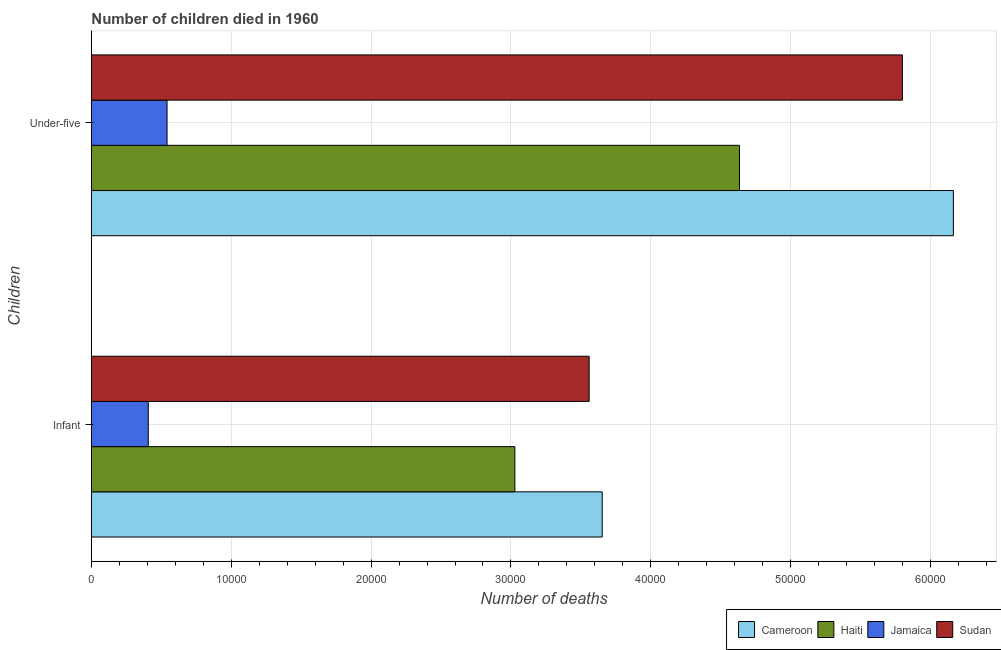Are the number of bars per tick equal to the number of legend labels?
Keep it short and to the point. Yes. How many bars are there on the 2nd tick from the bottom?
Keep it short and to the point. 4. What is the label of the 1st group of bars from the top?
Offer a terse response. Under-five. What is the number of infant deaths in Sudan?
Give a very brief answer. 3.56e+04. Across all countries, what is the maximum number of infant deaths?
Your answer should be very brief. 3.65e+04. Across all countries, what is the minimum number of under-five deaths?
Provide a short and direct response. 5408. In which country was the number of under-five deaths maximum?
Provide a short and direct response. Cameroon. In which country was the number of under-five deaths minimum?
Your answer should be compact. Jamaica. What is the total number of under-five deaths in the graph?
Offer a terse response. 1.71e+05. What is the difference between the number of infant deaths in Haiti and that in Jamaica?
Offer a terse response. 2.62e+04. What is the difference between the number of infant deaths in Cameroon and the number of under-five deaths in Sudan?
Offer a terse response. -2.15e+04. What is the average number of infant deaths per country?
Your response must be concise. 2.66e+04. What is the difference between the number of infant deaths and number of under-five deaths in Haiti?
Your answer should be compact. -1.61e+04. What is the ratio of the number of infant deaths in Sudan to that in Jamaica?
Your answer should be compact. 8.76. What does the 1st bar from the top in Under-five represents?
Your answer should be compact. Sudan. What does the 4th bar from the bottom in Infant represents?
Provide a short and direct response. Sudan. What is the difference between two consecutive major ticks on the X-axis?
Make the answer very short. 10000. Are the values on the major ticks of X-axis written in scientific E-notation?
Keep it short and to the point. No. Does the graph contain any zero values?
Provide a short and direct response. No. Does the graph contain grids?
Offer a terse response. Yes. How are the legend labels stacked?
Provide a short and direct response. Horizontal. What is the title of the graph?
Keep it short and to the point. Number of children died in 1960. What is the label or title of the X-axis?
Keep it short and to the point. Number of deaths. What is the label or title of the Y-axis?
Offer a very short reply. Children. What is the Number of deaths in Cameroon in Infant?
Your answer should be very brief. 3.65e+04. What is the Number of deaths in Haiti in Infant?
Provide a short and direct response. 3.03e+04. What is the Number of deaths in Jamaica in Infant?
Your answer should be compact. 4065. What is the Number of deaths in Sudan in Infant?
Keep it short and to the point. 3.56e+04. What is the Number of deaths in Cameroon in Under-five?
Your response must be concise. 6.16e+04. What is the Number of deaths of Haiti in Under-five?
Give a very brief answer. 4.63e+04. What is the Number of deaths of Jamaica in Under-five?
Provide a succinct answer. 5408. What is the Number of deaths in Sudan in Under-five?
Offer a terse response. 5.80e+04. Across all Children, what is the maximum Number of deaths in Cameroon?
Make the answer very short. 6.16e+04. Across all Children, what is the maximum Number of deaths of Haiti?
Your answer should be very brief. 4.63e+04. Across all Children, what is the maximum Number of deaths in Jamaica?
Provide a short and direct response. 5408. Across all Children, what is the maximum Number of deaths of Sudan?
Keep it short and to the point. 5.80e+04. Across all Children, what is the minimum Number of deaths of Cameroon?
Make the answer very short. 3.65e+04. Across all Children, what is the minimum Number of deaths in Haiti?
Provide a short and direct response. 3.03e+04. Across all Children, what is the minimum Number of deaths of Jamaica?
Your response must be concise. 4065. Across all Children, what is the minimum Number of deaths of Sudan?
Provide a succinct answer. 3.56e+04. What is the total Number of deaths of Cameroon in the graph?
Give a very brief answer. 9.82e+04. What is the total Number of deaths in Haiti in the graph?
Provide a short and direct response. 7.66e+04. What is the total Number of deaths of Jamaica in the graph?
Ensure brevity in your answer.  9473. What is the total Number of deaths in Sudan in the graph?
Your response must be concise. 9.36e+04. What is the difference between the Number of deaths in Cameroon in Infant and that in Under-five?
Offer a terse response. -2.51e+04. What is the difference between the Number of deaths of Haiti in Infant and that in Under-five?
Provide a succinct answer. -1.61e+04. What is the difference between the Number of deaths in Jamaica in Infant and that in Under-five?
Ensure brevity in your answer.  -1343. What is the difference between the Number of deaths in Sudan in Infant and that in Under-five?
Provide a succinct answer. -2.24e+04. What is the difference between the Number of deaths in Cameroon in Infant and the Number of deaths in Haiti in Under-five?
Give a very brief answer. -9816. What is the difference between the Number of deaths of Cameroon in Infant and the Number of deaths of Jamaica in Under-five?
Your response must be concise. 3.11e+04. What is the difference between the Number of deaths in Cameroon in Infant and the Number of deaths in Sudan in Under-five?
Make the answer very short. -2.15e+04. What is the difference between the Number of deaths of Haiti in Infant and the Number of deaths of Jamaica in Under-five?
Keep it short and to the point. 2.49e+04. What is the difference between the Number of deaths of Haiti in Infant and the Number of deaths of Sudan in Under-five?
Make the answer very short. -2.77e+04. What is the difference between the Number of deaths in Jamaica in Infant and the Number of deaths in Sudan in Under-five?
Your answer should be very brief. -5.39e+04. What is the average Number of deaths in Cameroon per Children?
Offer a terse response. 4.91e+04. What is the average Number of deaths in Haiti per Children?
Make the answer very short. 3.83e+04. What is the average Number of deaths in Jamaica per Children?
Give a very brief answer. 4736.5. What is the average Number of deaths of Sudan per Children?
Provide a succinct answer. 4.68e+04. What is the difference between the Number of deaths of Cameroon and Number of deaths of Haiti in Infant?
Keep it short and to the point. 6246. What is the difference between the Number of deaths in Cameroon and Number of deaths in Jamaica in Infant?
Provide a short and direct response. 3.25e+04. What is the difference between the Number of deaths in Cameroon and Number of deaths in Sudan in Infant?
Your answer should be very brief. 935. What is the difference between the Number of deaths in Haiti and Number of deaths in Jamaica in Infant?
Give a very brief answer. 2.62e+04. What is the difference between the Number of deaths in Haiti and Number of deaths in Sudan in Infant?
Provide a succinct answer. -5311. What is the difference between the Number of deaths in Jamaica and Number of deaths in Sudan in Infant?
Your answer should be very brief. -3.15e+04. What is the difference between the Number of deaths in Cameroon and Number of deaths in Haiti in Under-five?
Ensure brevity in your answer.  1.53e+04. What is the difference between the Number of deaths of Cameroon and Number of deaths of Jamaica in Under-five?
Your answer should be compact. 5.62e+04. What is the difference between the Number of deaths of Cameroon and Number of deaths of Sudan in Under-five?
Offer a terse response. 3646. What is the difference between the Number of deaths of Haiti and Number of deaths of Jamaica in Under-five?
Give a very brief answer. 4.09e+04. What is the difference between the Number of deaths in Haiti and Number of deaths in Sudan in Under-five?
Your response must be concise. -1.17e+04. What is the difference between the Number of deaths of Jamaica and Number of deaths of Sudan in Under-five?
Your answer should be compact. -5.26e+04. What is the ratio of the Number of deaths of Cameroon in Infant to that in Under-five?
Your answer should be very brief. 0.59. What is the ratio of the Number of deaths in Haiti in Infant to that in Under-five?
Give a very brief answer. 0.65. What is the ratio of the Number of deaths in Jamaica in Infant to that in Under-five?
Offer a terse response. 0.75. What is the ratio of the Number of deaths in Sudan in Infant to that in Under-five?
Provide a short and direct response. 0.61. What is the difference between the highest and the second highest Number of deaths in Cameroon?
Provide a short and direct response. 2.51e+04. What is the difference between the highest and the second highest Number of deaths in Haiti?
Give a very brief answer. 1.61e+04. What is the difference between the highest and the second highest Number of deaths of Jamaica?
Offer a terse response. 1343. What is the difference between the highest and the second highest Number of deaths of Sudan?
Ensure brevity in your answer.  2.24e+04. What is the difference between the highest and the lowest Number of deaths of Cameroon?
Provide a succinct answer. 2.51e+04. What is the difference between the highest and the lowest Number of deaths in Haiti?
Keep it short and to the point. 1.61e+04. What is the difference between the highest and the lowest Number of deaths of Jamaica?
Keep it short and to the point. 1343. What is the difference between the highest and the lowest Number of deaths of Sudan?
Offer a very short reply. 2.24e+04. 